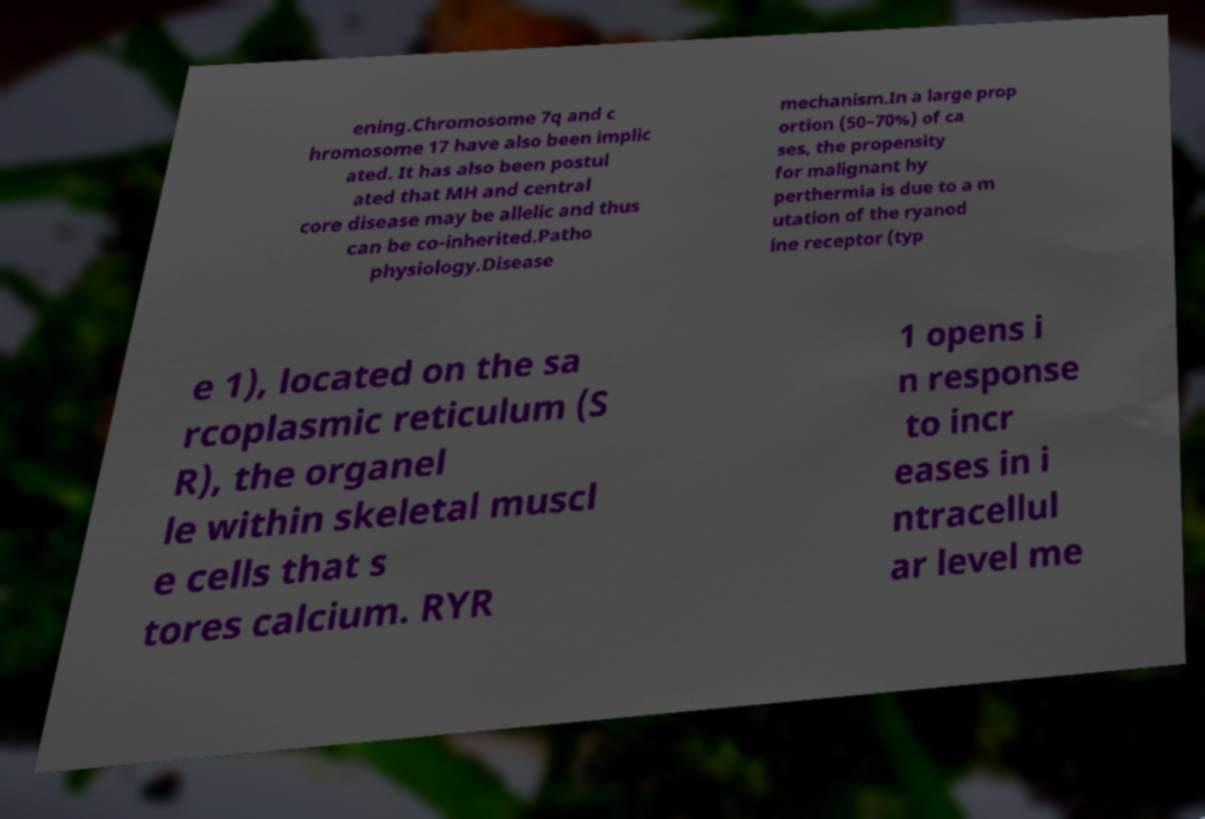For documentation purposes, I need the text within this image transcribed. Could you provide that? ening.Chromosome 7q and c hromosome 17 have also been implic ated. It has also been postul ated that MH and central core disease may be allelic and thus can be co-inherited.Patho physiology.Disease mechanism.In a large prop ortion (50–70%) of ca ses, the propensity for malignant hy perthermia is due to a m utation of the ryanod ine receptor (typ e 1), located on the sa rcoplasmic reticulum (S R), the organel le within skeletal muscl e cells that s tores calcium. RYR 1 opens i n response to incr eases in i ntracellul ar level me 